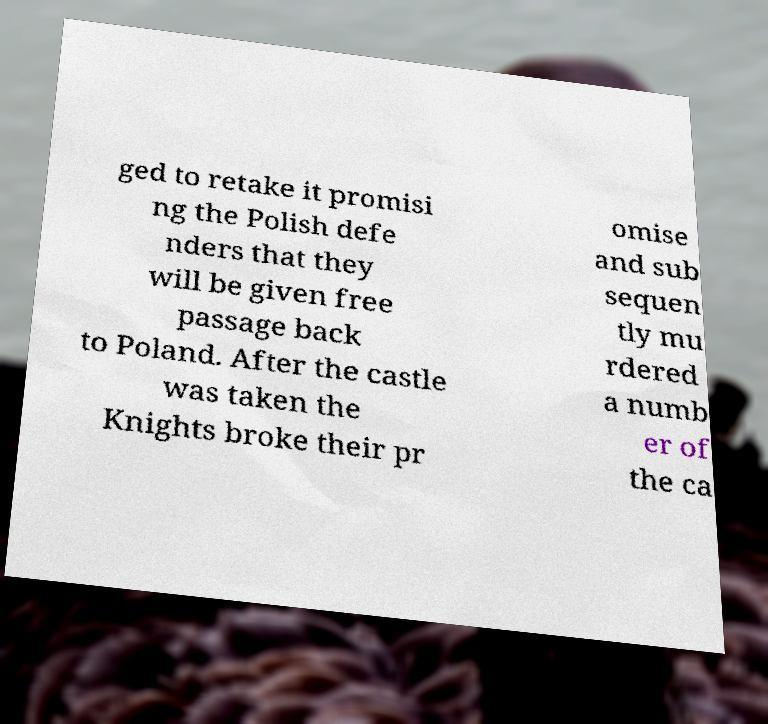Please read and relay the text visible in this image. What does it say? ged to retake it promisi ng the Polish defe nders that they will be given free passage back to Poland. After the castle was taken the Knights broke their pr omise and sub sequen tly mu rdered a numb er of the ca 